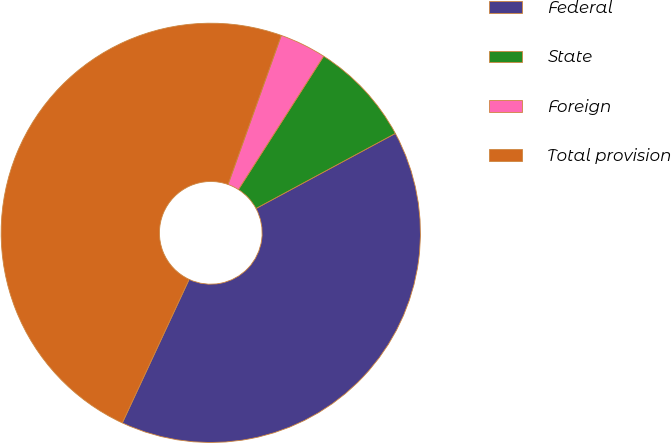Convert chart to OTSL. <chart><loc_0><loc_0><loc_500><loc_500><pie_chart><fcel>Federal<fcel>State<fcel>Foreign<fcel>Total provision<nl><fcel>39.8%<fcel>8.09%<fcel>3.59%<fcel>48.53%<nl></chart> 